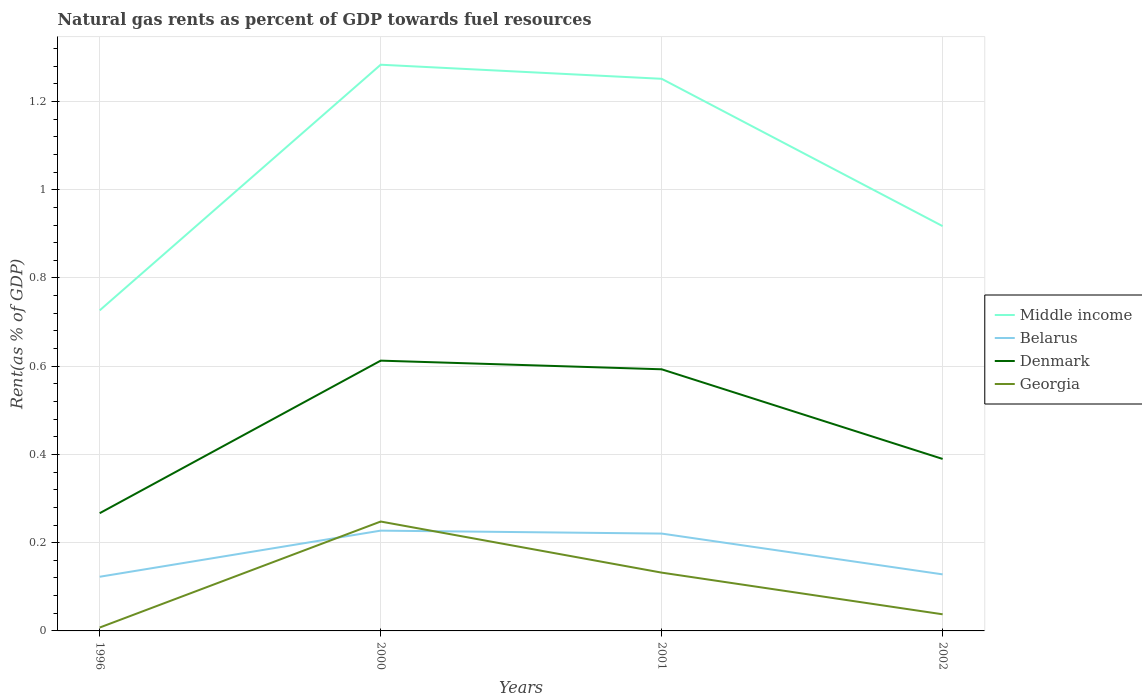How many different coloured lines are there?
Keep it short and to the point. 4. Across all years, what is the maximum matural gas rent in Belarus?
Provide a succinct answer. 0.12. What is the total matural gas rent in Denmark in the graph?
Offer a very short reply. 0.02. What is the difference between the highest and the second highest matural gas rent in Denmark?
Ensure brevity in your answer.  0.35. What is the difference between the highest and the lowest matural gas rent in Belarus?
Offer a very short reply. 2. How many lines are there?
Ensure brevity in your answer.  4. Does the graph contain any zero values?
Provide a short and direct response. No. Does the graph contain grids?
Provide a succinct answer. Yes. Where does the legend appear in the graph?
Your answer should be compact. Center right. How many legend labels are there?
Keep it short and to the point. 4. How are the legend labels stacked?
Your answer should be very brief. Vertical. What is the title of the graph?
Provide a short and direct response. Natural gas rents as percent of GDP towards fuel resources. Does "Ireland" appear as one of the legend labels in the graph?
Keep it short and to the point. No. What is the label or title of the Y-axis?
Make the answer very short. Rent(as % of GDP). What is the Rent(as % of GDP) in Middle income in 1996?
Give a very brief answer. 0.73. What is the Rent(as % of GDP) in Belarus in 1996?
Offer a terse response. 0.12. What is the Rent(as % of GDP) of Denmark in 1996?
Provide a short and direct response. 0.27. What is the Rent(as % of GDP) of Georgia in 1996?
Give a very brief answer. 0.01. What is the Rent(as % of GDP) in Middle income in 2000?
Provide a succinct answer. 1.28. What is the Rent(as % of GDP) of Belarus in 2000?
Ensure brevity in your answer.  0.23. What is the Rent(as % of GDP) in Denmark in 2000?
Provide a short and direct response. 0.61. What is the Rent(as % of GDP) of Georgia in 2000?
Your answer should be very brief. 0.25. What is the Rent(as % of GDP) in Middle income in 2001?
Offer a very short reply. 1.25. What is the Rent(as % of GDP) in Belarus in 2001?
Keep it short and to the point. 0.22. What is the Rent(as % of GDP) in Denmark in 2001?
Provide a short and direct response. 0.59. What is the Rent(as % of GDP) in Georgia in 2001?
Make the answer very short. 0.13. What is the Rent(as % of GDP) of Middle income in 2002?
Provide a short and direct response. 0.92. What is the Rent(as % of GDP) of Belarus in 2002?
Your answer should be compact. 0.13. What is the Rent(as % of GDP) of Denmark in 2002?
Provide a short and direct response. 0.39. What is the Rent(as % of GDP) of Georgia in 2002?
Your answer should be compact. 0.04. Across all years, what is the maximum Rent(as % of GDP) in Middle income?
Keep it short and to the point. 1.28. Across all years, what is the maximum Rent(as % of GDP) of Belarus?
Provide a succinct answer. 0.23. Across all years, what is the maximum Rent(as % of GDP) of Denmark?
Your response must be concise. 0.61. Across all years, what is the maximum Rent(as % of GDP) in Georgia?
Your answer should be very brief. 0.25. Across all years, what is the minimum Rent(as % of GDP) of Middle income?
Provide a succinct answer. 0.73. Across all years, what is the minimum Rent(as % of GDP) in Belarus?
Provide a short and direct response. 0.12. Across all years, what is the minimum Rent(as % of GDP) of Denmark?
Provide a short and direct response. 0.27. Across all years, what is the minimum Rent(as % of GDP) of Georgia?
Your response must be concise. 0.01. What is the total Rent(as % of GDP) of Middle income in the graph?
Provide a succinct answer. 4.18. What is the total Rent(as % of GDP) in Belarus in the graph?
Your answer should be compact. 0.7. What is the total Rent(as % of GDP) in Denmark in the graph?
Offer a terse response. 1.86. What is the total Rent(as % of GDP) in Georgia in the graph?
Make the answer very short. 0.43. What is the difference between the Rent(as % of GDP) in Middle income in 1996 and that in 2000?
Make the answer very short. -0.56. What is the difference between the Rent(as % of GDP) of Belarus in 1996 and that in 2000?
Make the answer very short. -0.1. What is the difference between the Rent(as % of GDP) of Denmark in 1996 and that in 2000?
Offer a terse response. -0.35. What is the difference between the Rent(as % of GDP) in Georgia in 1996 and that in 2000?
Your response must be concise. -0.24. What is the difference between the Rent(as % of GDP) of Middle income in 1996 and that in 2001?
Provide a short and direct response. -0.52. What is the difference between the Rent(as % of GDP) in Belarus in 1996 and that in 2001?
Your response must be concise. -0.1. What is the difference between the Rent(as % of GDP) in Denmark in 1996 and that in 2001?
Your answer should be compact. -0.33. What is the difference between the Rent(as % of GDP) of Georgia in 1996 and that in 2001?
Your response must be concise. -0.12. What is the difference between the Rent(as % of GDP) of Middle income in 1996 and that in 2002?
Give a very brief answer. -0.19. What is the difference between the Rent(as % of GDP) of Belarus in 1996 and that in 2002?
Give a very brief answer. -0.01. What is the difference between the Rent(as % of GDP) in Denmark in 1996 and that in 2002?
Keep it short and to the point. -0.12. What is the difference between the Rent(as % of GDP) of Georgia in 1996 and that in 2002?
Your answer should be compact. -0.03. What is the difference between the Rent(as % of GDP) in Middle income in 2000 and that in 2001?
Your answer should be very brief. 0.03. What is the difference between the Rent(as % of GDP) of Belarus in 2000 and that in 2001?
Ensure brevity in your answer.  0.01. What is the difference between the Rent(as % of GDP) in Denmark in 2000 and that in 2001?
Provide a short and direct response. 0.02. What is the difference between the Rent(as % of GDP) in Georgia in 2000 and that in 2001?
Your answer should be very brief. 0.12. What is the difference between the Rent(as % of GDP) of Middle income in 2000 and that in 2002?
Your answer should be compact. 0.37. What is the difference between the Rent(as % of GDP) of Belarus in 2000 and that in 2002?
Give a very brief answer. 0.1. What is the difference between the Rent(as % of GDP) in Denmark in 2000 and that in 2002?
Ensure brevity in your answer.  0.22. What is the difference between the Rent(as % of GDP) in Georgia in 2000 and that in 2002?
Provide a short and direct response. 0.21. What is the difference between the Rent(as % of GDP) of Middle income in 2001 and that in 2002?
Offer a terse response. 0.33. What is the difference between the Rent(as % of GDP) in Belarus in 2001 and that in 2002?
Provide a short and direct response. 0.09. What is the difference between the Rent(as % of GDP) in Denmark in 2001 and that in 2002?
Your answer should be compact. 0.2. What is the difference between the Rent(as % of GDP) of Georgia in 2001 and that in 2002?
Provide a short and direct response. 0.09. What is the difference between the Rent(as % of GDP) in Middle income in 1996 and the Rent(as % of GDP) in Belarus in 2000?
Provide a short and direct response. 0.5. What is the difference between the Rent(as % of GDP) of Middle income in 1996 and the Rent(as % of GDP) of Denmark in 2000?
Keep it short and to the point. 0.11. What is the difference between the Rent(as % of GDP) in Middle income in 1996 and the Rent(as % of GDP) in Georgia in 2000?
Your answer should be compact. 0.48. What is the difference between the Rent(as % of GDP) in Belarus in 1996 and the Rent(as % of GDP) in Denmark in 2000?
Offer a very short reply. -0.49. What is the difference between the Rent(as % of GDP) in Belarus in 1996 and the Rent(as % of GDP) in Georgia in 2000?
Provide a succinct answer. -0.13. What is the difference between the Rent(as % of GDP) in Denmark in 1996 and the Rent(as % of GDP) in Georgia in 2000?
Provide a succinct answer. 0.02. What is the difference between the Rent(as % of GDP) in Middle income in 1996 and the Rent(as % of GDP) in Belarus in 2001?
Offer a terse response. 0.51. What is the difference between the Rent(as % of GDP) of Middle income in 1996 and the Rent(as % of GDP) of Denmark in 2001?
Offer a terse response. 0.13. What is the difference between the Rent(as % of GDP) in Middle income in 1996 and the Rent(as % of GDP) in Georgia in 2001?
Offer a terse response. 0.59. What is the difference between the Rent(as % of GDP) in Belarus in 1996 and the Rent(as % of GDP) in Denmark in 2001?
Ensure brevity in your answer.  -0.47. What is the difference between the Rent(as % of GDP) of Belarus in 1996 and the Rent(as % of GDP) of Georgia in 2001?
Provide a short and direct response. -0.01. What is the difference between the Rent(as % of GDP) in Denmark in 1996 and the Rent(as % of GDP) in Georgia in 2001?
Ensure brevity in your answer.  0.13. What is the difference between the Rent(as % of GDP) in Middle income in 1996 and the Rent(as % of GDP) in Belarus in 2002?
Make the answer very short. 0.6. What is the difference between the Rent(as % of GDP) of Middle income in 1996 and the Rent(as % of GDP) of Denmark in 2002?
Your response must be concise. 0.34. What is the difference between the Rent(as % of GDP) in Middle income in 1996 and the Rent(as % of GDP) in Georgia in 2002?
Provide a short and direct response. 0.69. What is the difference between the Rent(as % of GDP) of Belarus in 1996 and the Rent(as % of GDP) of Denmark in 2002?
Your answer should be compact. -0.27. What is the difference between the Rent(as % of GDP) in Belarus in 1996 and the Rent(as % of GDP) in Georgia in 2002?
Offer a very short reply. 0.09. What is the difference between the Rent(as % of GDP) of Denmark in 1996 and the Rent(as % of GDP) of Georgia in 2002?
Give a very brief answer. 0.23. What is the difference between the Rent(as % of GDP) of Middle income in 2000 and the Rent(as % of GDP) of Belarus in 2001?
Give a very brief answer. 1.06. What is the difference between the Rent(as % of GDP) in Middle income in 2000 and the Rent(as % of GDP) in Denmark in 2001?
Make the answer very short. 0.69. What is the difference between the Rent(as % of GDP) in Middle income in 2000 and the Rent(as % of GDP) in Georgia in 2001?
Your answer should be very brief. 1.15. What is the difference between the Rent(as % of GDP) of Belarus in 2000 and the Rent(as % of GDP) of Denmark in 2001?
Keep it short and to the point. -0.37. What is the difference between the Rent(as % of GDP) in Belarus in 2000 and the Rent(as % of GDP) in Georgia in 2001?
Provide a short and direct response. 0.1. What is the difference between the Rent(as % of GDP) of Denmark in 2000 and the Rent(as % of GDP) of Georgia in 2001?
Your response must be concise. 0.48. What is the difference between the Rent(as % of GDP) of Middle income in 2000 and the Rent(as % of GDP) of Belarus in 2002?
Give a very brief answer. 1.16. What is the difference between the Rent(as % of GDP) of Middle income in 2000 and the Rent(as % of GDP) of Denmark in 2002?
Give a very brief answer. 0.89. What is the difference between the Rent(as % of GDP) of Middle income in 2000 and the Rent(as % of GDP) of Georgia in 2002?
Your answer should be very brief. 1.25. What is the difference between the Rent(as % of GDP) in Belarus in 2000 and the Rent(as % of GDP) in Denmark in 2002?
Make the answer very short. -0.16. What is the difference between the Rent(as % of GDP) of Belarus in 2000 and the Rent(as % of GDP) of Georgia in 2002?
Ensure brevity in your answer.  0.19. What is the difference between the Rent(as % of GDP) of Denmark in 2000 and the Rent(as % of GDP) of Georgia in 2002?
Your response must be concise. 0.57. What is the difference between the Rent(as % of GDP) in Middle income in 2001 and the Rent(as % of GDP) in Belarus in 2002?
Make the answer very short. 1.12. What is the difference between the Rent(as % of GDP) in Middle income in 2001 and the Rent(as % of GDP) in Denmark in 2002?
Ensure brevity in your answer.  0.86. What is the difference between the Rent(as % of GDP) of Middle income in 2001 and the Rent(as % of GDP) of Georgia in 2002?
Keep it short and to the point. 1.21. What is the difference between the Rent(as % of GDP) in Belarus in 2001 and the Rent(as % of GDP) in Denmark in 2002?
Offer a terse response. -0.17. What is the difference between the Rent(as % of GDP) of Belarus in 2001 and the Rent(as % of GDP) of Georgia in 2002?
Give a very brief answer. 0.18. What is the difference between the Rent(as % of GDP) in Denmark in 2001 and the Rent(as % of GDP) in Georgia in 2002?
Offer a very short reply. 0.56. What is the average Rent(as % of GDP) of Middle income per year?
Your response must be concise. 1.04. What is the average Rent(as % of GDP) of Belarus per year?
Ensure brevity in your answer.  0.17. What is the average Rent(as % of GDP) of Denmark per year?
Provide a short and direct response. 0.47. What is the average Rent(as % of GDP) of Georgia per year?
Your answer should be compact. 0.11. In the year 1996, what is the difference between the Rent(as % of GDP) in Middle income and Rent(as % of GDP) in Belarus?
Provide a succinct answer. 0.6. In the year 1996, what is the difference between the Rent(as % of GDP) in Middle income and Rent(as % of GDP) in Denmark?
Make the answer very short. 0.46. In the year 1996, what is the difference between the Rent(as % of GDP) of Middle income and Rent(as % of GDP) of Georgia?
Provide a succinct answer. 0.72. In the year 1996, what is the difference between the Rent(as % of GDP) in Belarus and Rent(as % of GDP) in Denmark?
Provide a succinct answer. -0.14. In the year 1996, what is the difference between the Rent(as % of GDP) in Belarus and Rent(as % of GDP) in Georgia?
Ensure brevity in your answer.  0.12. In the year 1996, what is the difference between the Rent(as % of GDP) in Denmark and Rent(as % of GDP) in Georgia?
Your answer should be very brief. 0.26. In the year 2000, what is the difference between the Rent(as % of GDP) in Middle income and Rent(as % of GDP) in Belarus?
Ensure brevity in your answer.  1.06. In the year 2000, what is the difference between the Rent(as % of GDP) in Middle income and Rent(as % of GDP) in Denmark?
Provide a short and direct response. 0.67. In the year 2000, what is the difference between the Rent(as % of GDP) in Middle income and Rent(as % of GDP) in Georgia?
Give a very brief answer. 1.04. In the year 2000, what is the difference between the Rent(as % of GDP) in Belarus and Rent(as % of GDP) in Denmark?
Keep it short and to the point. -0.39. In the year 2000, what is the difference between the Rent(as % of GDP) in Belarus and Rent(as % of GDP) in Georgia?
Your answer should be compact. -0.02. In the year 2000, what is the difference between the Rent(as % of GDP) of Denmark and Rent(as % of GDP) of Georgia?
Your response must be concise. 0.36. In the year 2001, what is the difference between the Rent(as % of GDP) of Middle income and Rent(as % of GDP) of Belarus?
Make the answer very short. 1.03. In the year 2001, what is the difference between the Rent(as % of GDP) of Middle income and Rent(as % of GDP) of Denmark?
Provide a succinct answer. 0.66. In the year 2001, what is the difference between the Rent(as % of GDP) in Middle income and Rent(as % of GDP) in Georgia?
Provide a succinct answer. 1.12. In the year 2001, what is the difference between the Rent(as % of GDP) of Belarus and Rent(as % of GDP) of Denmark?
Your answer should be compact. -0.37. In the year 2001, what is the difference between the Rent(as % of GDP) in Belarus and Rent(as % of GDP) in Georgia?
Provide a short and direct response. 0.09. In the year 2001, what is the difference between the Rent(as % of GDP) of Denmark and Rent(as % of GDP) of Georgia?
Make the answer very short. 0.46. In the year 2002, what is the difference between the Rent(as % of GDP) in Middle income and Rent(as % of GDP) in Belarus?
Your answer should be compact. 0.79. In the year 2002, what is the difference between the Rent(as % of GDP) in Middle income and Rent(as % of GDP) in Denmark?
Provide a short and direct response. 0.53. In the year 2002, what is the difference between the Rent(as % of GDP) of Middle income and Rent(as % of GDP) of Georgia?
Give a very brief answer. 0.88. In the year 2002, what is the difference between the Rent(as % of GDP) of Belarus and Rent(as % of GDP) of Denmark?
Provide a succinct answer. -0.26. In the year 2002, what is the difference between the Rent(as % of GDP) of Belarus and Rent(as % of GDP) of Georgia?
Offer a terse response. 0.09. In the year 2002, what is the difference between the Rent(as % of GDP) in Denmark and Rent(as % of GDP) in Georgia?
Provide a succinct answer. 0.35. What is the ratio of the Rent(as % of GDP) in Middle income in 1996 to that in 2000?
Offer a terse response. 0.57. What is the ratio of the Rent(as % of GDP) in Belarus in 1996 to that in 2000?
Offer a terse response. 0.54. What is the ratio of the Rent(as % of GDP) in Denmark in 1996 to that in 2000?
Provide a short and direct response. 0.44. What is the ratio of the Rent(as % of GDP) in Georgia in 1996 to that in 2000?
Ensure brevity in your answer.  0.03. What is the ratio of the Rent(as % of GDP) in Middle income in 1996 to that in 2001?
Offer a very short reply. 0.58. What is the ratio of the Rent(as % of GDP) of Belarus in 1996 to that in 2001?
Ensure brevity in your answer.  0.56. What is the ratio of the Rent(as % of GDP) of Denmark in 1996 to that in 2001?
Offer a terse response. 0.45. What is the ratio of the Rent(as % of GDP) in Georgia in 1996 to that in 2001?
Make the answer very short. 0.06. What is the ratio of the Rent(as % of GDP) in Middle income in 1996 to that in 2002?
Offer a very short reply. 0.79. What is the ratio of the Rent(as % of GDP) in Belarus in 1996 to that in 2002?
Make the answer very short. 0.96. What is the ratio of the Rent(as % of GDP) of Denmark in 1996 to that in 2002?
Your answer should be compact. 0.68. What is the ratio of the Rent(as % of GDP) of Georgia in 1996 to that in 2002?
Your answer should be very brief. 0.2. What is the ratio of the Rent(as % of GDP) in Middle income in 2000 to that in 2001?
Keep it short and to the point. 1.03. What is the ratio of the Rent(as % of GDP) in Belarus in 2000 to that in 2001?
Offer a very short reply. 1.03. What is the ratio of the Rent(as % of GDP) of Denmark in 2000 to that in 2001?
Keep it short and to the point. 1.03. What is the ratio of the Rent(as % of GDP) of Georgia in 2000 to that in 2001?
Give a very brief answer. 1.88. What is the ratio of the Rent(as % of GDP) of Middle income in 2000 to that in 2002?
Make the answer very short. 1.4. What is the ratio of the Rent(as % of GDP) of Belarus in 2000 to that in 2002?
Give a very brief answer. 1.77. What is the ratio of the Rent(as % of GDP) in Denmark in 2000 to that in 2002?
Keep it short and to the point. 1.57. What is the ratio of the Rent(as % of GDP) in Georgia in 2000 to that in 2002?
Provide a succinct answer. 6.58. What is the ratio of the Rent(as % of GDP) of Middle income in 2001 to that in 2002?
Make the answer very short. 1.36. What is the ratio of the Rent(as % of GDP) in Belarus in 2001 to that in 2002?
Make the answer very short. 1.72. What is the ratio of the Rent(as % of GDP) of Denmark in 2001 to that in 2002?
Ensure brevity in your answer.  1.52. What is the ratio of the Rent(as % of GDP) in Georgia in 2001 to that in 2002?
Provide a short and direct response. 3.51. What is the difference between the highest and the second highest Rent(as % of GDP) in Middle income?
Your answer should be very brief. 0.03. What is the difference between the highest and the second highest Rent(as % of GDP) in Belarus?
Provide a short and direct response. 0.01. What is the difference between the highest and the second highest Rent(as % of GDP) of Denmark?
Offer a terse response. 0.02. What is the difference between the highest and the second highest Rent(as % of GDP) in Georgia?
Keep it short and to the point. 0.12. What is the difference between the highest and the lowest Rent(as % of GDP) in Middle income?
Provide a succinct answer. 0.56. What is the difference between the highest and the lowest Rent(as % of GDP) in Belarus?
Keep it short and to the point. 0.1. What is the difference between the highest and the lowest Rent(as % of GDP) in Denmark?
Offer a very short reply. 0.35. What is the difference between the highest and the lowest Rent(as % of GDP) in Georgia?
Your answer should be compact. 0.24. 